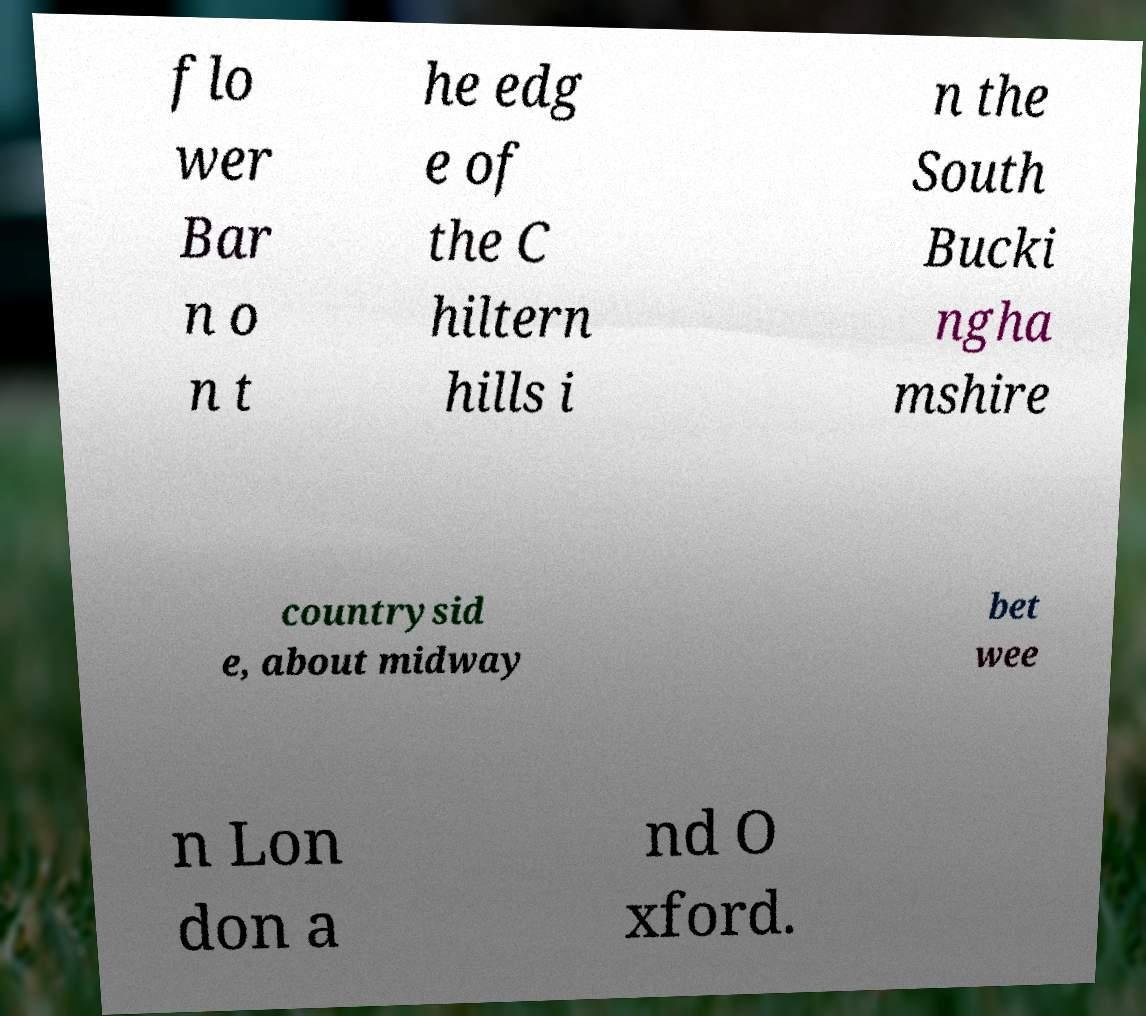For documentation purposes, I need the text within this image transcribed. Could you provide that? flo wer Bar n o n t he edg e of the C hiltern hills i n the South Bucki ngha mshire countrysid e, about midway bet wee n Lon don a nd O xford. 